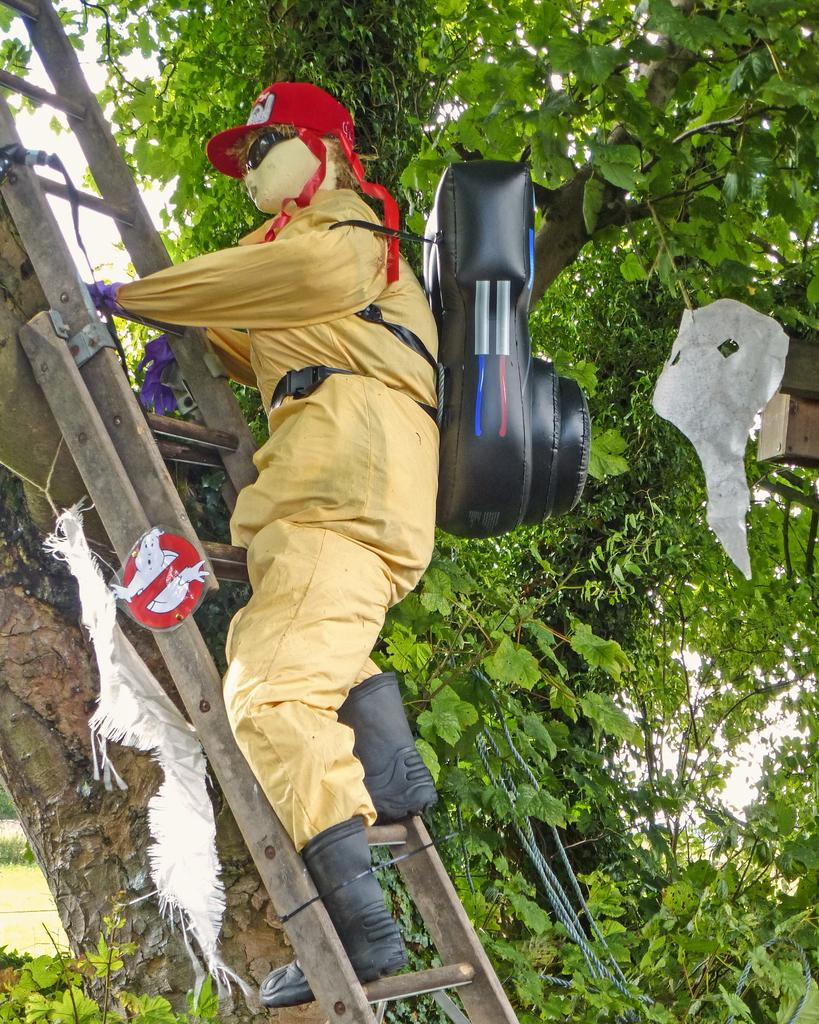What is the main subject in the image? There is a doll in the image. Where is the doll located? The doll is on a ladder. What can be seen in the background of the image? There are trees in the background of the image. What type of hook is the doll using to climb the ladder in the image? There is no hook present in the image; the doll is simply on the ladder. 